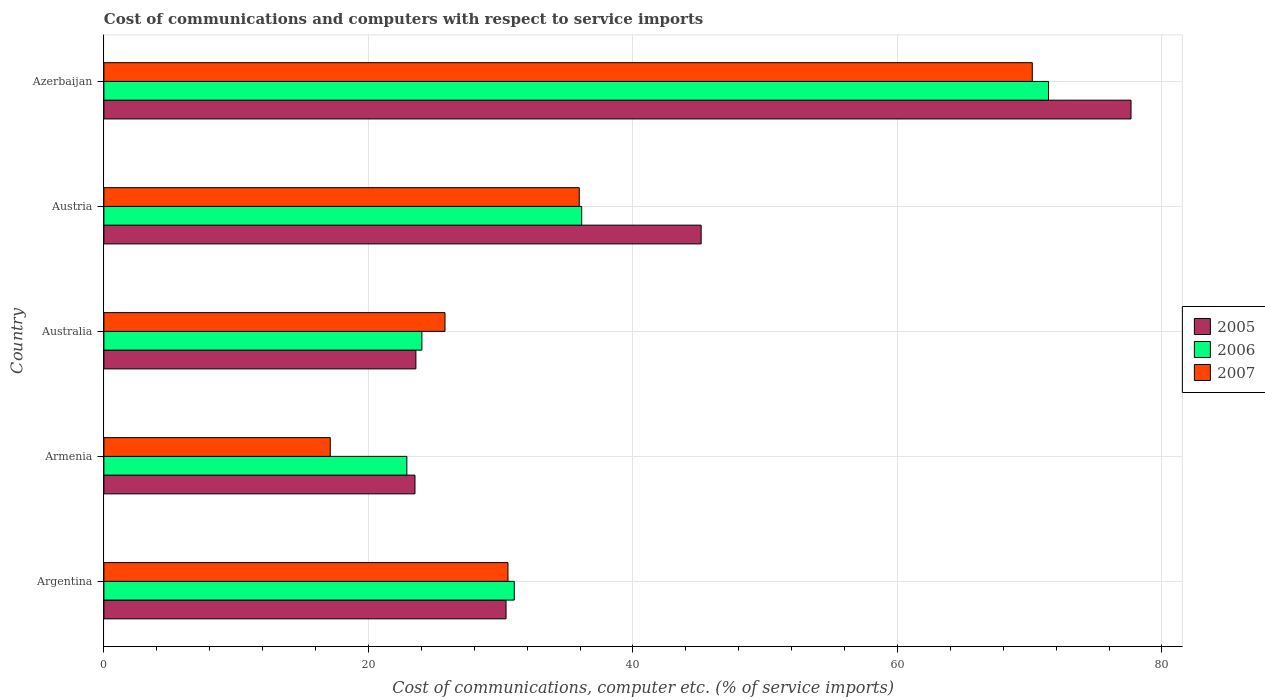Are the number of bars per tick equal to the number of legend labels?
Provide a short and direct response. Yes. Are the number of bars on each tick of the Y-axis equal?
Your response must be concise. Yes. How many bars are there on the 3rd tick from the top?
Make the answer very short. 3. What is the label of the 3rd group of bars from the top?
Provide a short and direct response. Australia. What is the cost of communications and computers in 2007 in Australia?
Make the answer very short. 25.79. Across all countries, what is the maximum cost of communications and computers in 2006?
Provide a succinct answer. 71.43. Across all countries, what is the minimum cost of communications and computers in 2006?
Your response must be concise. 22.91. In which country was the cost of communications and computers in 2005 maximum?
Make the answer very short. Azerbaijan. In which country was the cost of communications and computers in 2005 minimum?
Provide a succinct answer. Armenia. What is the total cost of communications and computers in 2005 in the graph?
Offer a terse response. 200.35. What is the difference between the cost of communications and computers in 2005 in Argentina and that in Azerbaijan?
Keep it short and to the point. -47.26. What is the difference between the cost of communications and computers in 2005 in Argentina and the cost of communications and computers in 2007 in Australia?
Your answer should be compact. 4.62. What is the average cost of communications and computers in 2005 per country?
Provide a short and direct response. 40.07. What is the difference between the cost of communications and computers in 2006 and cost of communications and computers in 2005 in Argentina?
Your response must be concise. 0.62. In how many countries, is the cost of communications and computers in 2007 greater than 40 %?
Offer a terse response. 1. What is the ratio of the cost of communications and computers in 2006 in Argentina to that in Austria?
Provide a short and direct response. 0.86. What is the difference between the highest and the second highest cost of communications and computers in 2005?
Ensure brevity in your answer.  32.5. What is the difference between the highest and the lowest cost of communications and computers in 2007?
Your response must be concise. 53.08. In how many countries, is the cost of communications and computers in 2005 greater than the average cost of communications and computers in 2005 taken over all countries?
Offer a terse response. 2. What does the 2nd bar from the top in Austria represents?
Offer a very short reply. 2006. Is it the case that in every country, the sum of the cost of communications and computers in 2005 and cost of communications and computers in 2007 is greater than the cost of communications and computers in 2006?
Ensure brevity in your answer.  Yes. How many bars are there?
Provide a succinct answer. 15. Are all the bars in the graph horizontal?
Your response must be concise. Yes. How many countries are there in the graph?
Offer a very short reply. 5. Are the values on the major ticks of X-axis written in scientific E-notation?
Offer a terse response. No. Does the graph contain any zero values?
Give a very brief answer. No. Does the graph contain grids?
Provide a succinct answer. Yes. Where does the legend appear in the graph?
Give a very brief answer. Center right. How many legend labels are there?
Provide a succinct answer. 3. What is the title of the graph?
Offer a terse response. Cost of communications and computers with respect to service imports. What is the label or title of the X-axis?
Offer a very short reply. Cost of communications, computer etc. (% of service imports). What is the Cost of communications, computer etc. (% of service imports) of 2005 in Argentina?
Offer a terse response. 30.41. What is the Cost of communications, computer etc. (% of service imports) of 2006 in Argentina?
Keep it short and to the point. 31.03. What is the Cost of communications, computer etc. (% of service imports) of 2007 in Argentina?
Make the answer very short. 30.55. What is the Cost of communications, computer etc. (% of service imports) in 2005 in Armenia?
Offer a very short reply. 23.52. What is the Cost of communications, computer etc. (% of service imports) in 2006 in Armenia?
Offer a very short reply. 22.91. What is the Cost of communications, computer etc. (% of service imports) in 2007 in Armenia?
Ensure brevity in your answer.  17.12. What is the Cost of communications, computer etc. (% of service imports) in 2005 in Australia?
Offer a very short reply. 23.59. What is the Cost of communications, computer etc. (% of service imports) in 2006 in Australia?
Provide a succinct answer. 24.05. What is the Cost of communications, computer etc. (% of service imports) in 2007 in Australia?
Your answer should be very brief. 25.79. What is the Cost of communications, computer etc. (% of service imports) of 2005 in Austria?
Offer a very short reply. 45.16. What is the Cost of communications, computer etc. (% of service imports) of 2006 in Austria?
Provide a short and direct response. 36.13. What is the Cost of communications, computer etc. (% of service imports) in 2007 in Austria?
Give a very brief answer. 35.94. What is the Cost of communications, computer etc. (% of service imports) in 2005 in Azerbaijan?
Offer a terse response. 77.66. What is the Cost of communications, computer etc. (% of service imports) of 2006 in Azerbaijan?
Make the answer very short. 71.43. What is the Cost of communications, computer etc. (% of service imports) in 2007 in Azerbaijan?
Your response must be concise. 70.2. Across all countries, what is the maximum Cost of communications, computer etc. (% of service imports) of 2005?
Provide a short and direct response. 77.66. Across all countries, what is the maximum Cost of communications, computer etc. (% of service imports) in 2006?
Ensure brevity in your answer.  71.43. Across all countries, what is the maximum Cost of communications, computer etc. (% of service imports) of 2007?
Offer a terse response. 70.2. Across all countries, what is the minimum Cost of communications, computer etc. (% of service imports) of 2005?
Your response must be concise. 23.52. Across all countries, what is the minimum Cost of communications, computer etc. (% of service imports) in 2006?
Give a very brief answer. 22.91. Across all countries, what is the minimum Cost of communications, computer etc. (% of service imports) of 2007?
Ensure brevity in your answer.  17.12. What is the total Cost of communications, computer etc. (% of service imports) in 2005 in the graph?
Your answer should be compact. 200.35. What is the total Cost of communications, computer etc. (% of service imports) of 2006 in the graph?
Provide a short and direct response. 185.54. What is the total Cost of communications, computer etc. (% of service imports) in 2007 in the graph?
Make the answer very short. 179.6. What is the difference between the Cost of communications, computer etc. (% of service imports) of 2005 in Argentina and that in Armenia?
Your answer should be compact. 6.88. What is the difference between the Cost of communications, computer etc. (% of service imports) in 2006 in Argentina and that in Armenia?
Make the answer very short. 8.12. What is the difference between the Cost of communications, computer etc. (% of service imports) of 2007 in Argentina and that in Armenia?
Your answer should be compact. 13.44. What is the difference between the Cost of communications, computer etc. (% of service imports) in 2005 in Argentina and that in Australia?
Your response must be concise. 6.82. What is the difference between the Cost of communications, computer etc. (% of service imports) of 2006 in Argentina and that in Australia?
Offer a very short reply. 6.98. What is the difference between the Cost of communications, computer etc. (% of service imports) of 2007 in Argentina and that in Australia?
Your answer should be very brief. 4.76. What is the difference between the Cost of communications, computer etc. (% of service imports) in 2005 in Argentina and that in Austria?
Provide a succinct answer. -14.75. What is the difference between the Cost of communications, computer etc. (% of service imports) in 2006 in Argentina and that in Austria?
Offer a very short reply. -5.1. What is the difference between the Cost of communications, computer etc. (% of service imports) of 2007 in Argentina and that in Austria?
Make the answer very short. -5.39. What is the difference between the Cost of communications, computer etc. (% of service imports) in 2005 in Argentina and that in Azerbaijan?
Provide a succinct answer. -47.26. What is the difference between the Cost of communications, computer etc. (% of service imports) in 2006 in Argentina and that in Azerbaijan?
Keep it short and to the point. -40.4. What is the difference between the Cost of communications, computer etc. (% of service imports) of 2007 in Argentina and that in Azerbaijan?
Offer a very short reply. -39.65. What is the difference between the Cost of communications, computer etc. (% of service imports) of 2005 in Armenia and that in Australia?
Give a very brief answer. -0.07. What is the difference between the Cost of communications, computer etc. (% of service imports) in 2006 in Armenia and that in Australia?
Give a very brief answer. -1.14. What is the difference between the Cost of communications, computer etc. (% of service imports) in 2007 in Armenia and that in Australia?
Make the answer very short. -8.68. What is the difference between the Cost of communications, computer etc. (% of service imports) of 2005 in Armenia and that in Austria?
Your answer should be very brief. -21.64. What is the difference between the Cost of communications, computer etc. (% of service imports) of 2006 in Armenia and that in Austria?
Offer a terse response. -13.22. What is the difference between the Cost of communications, computer etc. (% of service imports) in 2007 in Armenia and that in Austria?
Give a very brief answer. -18.83. What is the difference between the Cost of communications, computer etc. (% of service imports) in 2005 in Armenia and that in Azerbaijan?
Ensure brevity in your answer.  -54.14. What is the difference between the Cost of communications, computer etc. (% of service imports) in 2006 in Armenia and that in Azerbaijan?
Ensure brevity in your answer.  -48.52. What is the difference between the Cost of communications, computer etc. (% of service imports) of 2007 in Armenia and that in Azerbaijan?
Give a very brief answer. -53.08. What is the difference between the Cost of communications, computer etc. (% of service imports) in 2005 in Australia and that in Austria?
Keep it short and to the point. -21.57. What is the difference between the Cost of communications, computer etc. (% of service imports) in 2006 in Australia and that in Austria?
Keep it short and to the point. -12.08. What is the difference between the Cost of communications, computer etc. (% of service imports) in 2007 in Australia and that in Austria?
Provide a succinct answer. -10.15. What is the difference between the Cost of communications, computer etc. (% of service imports) of 2005 in Australia and that in Azerbaijan?
Your answer should be very brief. -54.07. What is the difference between the Cost of communications, computer etc. (% of service imports) in 2006 in Australia and that in Azerbaijan?
Provide a succinct answer. -47.38. What is the difference between the Cost of communications, computer etc. (% of service imports) in 2007 in Australia and that in Azerbaijan?
Keep it short and to the point. -44.41. What is the difference between the Cost of communications, computer etc. (% of service imports) in 2005 in Austria and that in Azerbaijan?
Ensure brevity in your answer.  -32.5. What is the difference between the Cost of communications, computer etc. (% of service imports) in 2006 in Austria and that in Azerbaijan?
Your answer should be compact. -35.3. What is the difference between the Cost of communications, computer etc. (% of service imports) of 2007 in Austria and that in Azerbaijan?
Your answer should be very brief. -34.26. What is the difference between the Cost of communications, computer etc. (% of service imports) of 2005 in Argentina and the Cost of communications, computer etc. (% of service imports) of 2007 in Armenia?
Your answer should be compact. 13.29. What is the difference between the Cost of communications, computer etc. (% of service imports) of 2006 in Argentina and the Cost of communications, computer etc. (% of service imports) of 2007 in Armenia?
Ensure brevity in your answer.  13.91. What is the difference between the Cost of communications, computer etc. (% of service imports) in 2005 in Argentina and the Cost of communications, computer etc. (% of service imports) in 2006 in Australia?
Offer a very short reply. 6.36. What is the difference between the Cost of communications, computer etc. (% of service imports) in 2005 in Argentina and the Cost of communications, computer etc. (% of service imports) in 2007 in Australia?
Ensure brevity in your answer.  4.62. What is the difference between the Cost of communications, computer etc. (% of service imports) of 2006 in Argentina and the Cost of communications, computer etc. (% of service imports) of 2007 in Australia?
Your answer should be very brief. 5.24. What is the difference between the Cost of communications, computer etc. (% of service imports) in 2005 in Argentina and the Cost of communications, computer etc. (% of service imports) in 2006 in Austria?
Offer a very short reply. -5.72. What is the difference between the Cost of communications, computer etc. (% of service imports) of 2005 in Argentina and the Cost of communications, computer etc. (% of service imports) of 2007 in Austria?
Offer a very short reply. -5.54. What is the difference between the Cost of communications, computer etc. (% of service imports) of 2006 in Argentina and the Cost of communications, computer etc. (% of service imports) of 2007 in Austria?
Your response must be concise. -4.91. What is the difference between the Cost of communications, computer etc. (% of service imports) in 2005 in Argentina and the Cost of communications, computer etc. (% of service imports) in 2006 in Azerbaijan?
Provide a short and direct response. -41.02. What is the difference between the Cost of communications, computer etc. (% of service imports) in 2005 in Argentina and the Cost of communications, computer etc. (% of service imports) in 2007 in Azerbaijan?
Give a very brief answer. -39.79. What is the difference between the Cost of communications, computer etc. (% of service imports) in 2006 in Argentina and the Cost of communications, computer etc. (% of service imports) in 2007 in Azerbaijan?
Provide a succinct answer. -39.17. What is the difference between the Cost of communications, computer etc. (% of service imports) of 2005 in Armenia and the Cost of communications, computer etc. (% of service imports) of 2006 in Australia?
Keep it short and to the point. -0.52. What is the difference between the Cost of communications, computer etc. (% of service imports) in 2005 in Armenia and the Cost of communications, computer etc. (% of service imports) in 2007 in Australia?
Provide a succinct answer. -2.27. What is the difference between the Cost of communications, computer etc. (% of service imports) of 2006 in Armenia and the Cost of communications, computer etc. (% of service imports) of 2007 in Australia?
Offer a terse response. -2.88. What is the difference between the Cost of communications, computer etc. (% of service imports) of 2005 in Armenia and the Cost of communications, computer etc. (% of service imports) of 2006 in Austria?
Keep it short and to the point. -12.6. What is the difference between the Cost of communications, computer etc. (% of service imports) of 2005 in Armenia and the Cost of communications, computer etc. (% of service imports) of 2007 in Austria?
Offer a terse response. -12.42. What is the difference between the Cost of communications, computer etc. (% of service imports) of 2006 in Armenia and the Cost of communications, computer etc. (% of service imports) of 2007 in Austria?
Your answer should be compact. -13.04. What is the difference between the Cost of communications, computer etc. (% of service imports) in 2005 in Armenia and the Cost of communications, computer etc. (% of service imports) in 2006 in Azerbaijan?
Provide a short and direct response. -47.91. What is the difference between the Cost of communications, computer etc. (% of service imports) in 2005 in Armenia and the Cost of communications, computer etc. (% of service imports) in 2007 in Azerbaijan?
Your answer should be very brief. -46.68. What is the difference between the Cost of communications, computer etc. (% of service imports) of 2006 in Armenia and the Cost of communications, computer etc. (% of service imports) of 2007 in Azerbaijan?
Your response must be concise. -47.29. What is the difference between the Cost of communications, computer etc. (% of service imports) in 2005 in Australia and the Cost of communications, computer etc. (% of service imports) in 2006 in Austria?
Ensure brevity in your answer.  -12.54. What is the difference between the Cost of communications, computer etc. (% of service imports) of 2005 in Australia and the Cost of communications, computer etc. (% of service imports) of 2007 in Austria?
Provide a short and direct response. -12.35. What is the difference between the Cost of communications, computer etc. (% of service imports) in 2006 in Australia and the Cost of communications, computer etc. (% of service imports) in 2007 in Austria?
Ensure brevity in your answer.  -11.9. What is the difference between the Cost of communications, computer etc. (% of service imports) in 2005 in Australia and the Cost of communications, computer etc. (% of service imports) in 2006 in Azerbaijan?
Offer a very short reply. -47.84. What is the difference between the Cost of communications, computer etc. (% of service imports) in 2005 in Australia and the Cost of communications, computer etc. (% of service imports) in 2007 in Azerbaijan?
Make the answer very short. -46.61. What is the difference between the Cost of communications, computer etc. (% of service imports) of 2006 in Australia and the Cost of communications, computer etc. (% of service imports) of 2007 in Azerbaijan?
Provide a succinct answer. -46.15. What is the difference between the Cost of communications, computer etc. (% of service imports) of 2005 in Austria and the Cost of communications, computer etc. (% of service imports) of 2006 in Azerbaijan?
Keep it short and to the point. -26.27. What is the difference between the Cost of communications, computer etc. (% of service imports) of 2005 in Austria and the Cost of communications, computer etc. (% of service imports) of 2007 in Azerbaijan?
Your response must be concise. -25.04. What is the difference between the Cost of communications, computer etc. (% of service imports) of 2006 in Austria and the Cost of communications, computer etc. (% of service imports) of 2007 in Azerbaijan?
Make the answer very short. -34.07. What is the average Cost of communications, computer etc. (% of service imports) in 2005 per country?
Your answer should be very brief. 40.07. What is the average Cost of communications, computer etc. (% of service imports) in 2006 per country?
Your answer should be very brief. 37.11. What is the average Cost of communications, computer etc. (% of service imports) of 2007 per country?
Your answer should be compact. 35.92. What is the difference between the Cost of communications, computer etc. (% of service imports) of 2005 and Cost of communications, computer etc. (% of service imports) of 2006 in Argentina?
Keep it short and to the point. -0.62. What is the difference between the Cost of communications, computer etc. (% of service imports) in 2005 and Cost of communications, computer etc. (% of service imports) in 2007 in Argentina?
Keep it short and to the point. -0.15. What is the difference between the Cost of communications, computer etc. (% of service imports) in 2006 and Cost of communications, computer etc. (% of service imports) in 2007 in Argentina?
Your response must be concise. 0.48. What is the difference between the Cost of communications, computer etc. (% of service imports) in 2005 and Cost of communications, computer etc. (% of service imports) in 2006 in Armenia?
Give a very brief answer. 0.61. What is the difference between the Cost of communications, computer etc. (% of service imports) in 2005 and Cost of communications, computer etc. (% of service imports) in 2007 in Armenia?
Your answer should be very brief. 6.41. What is the difference between the Cost of communications, computer etc. (% of service imports) of 2006 and Cost of communications, computer etc. (% of service imports) of 2007 in Armenia?
Your response must be concise. 5.79. What is the difference between the Cost of communications, computer etc. (% of service imports) of 2005 and Cost of communications, computer etc. (% of service imports) of 2006 in Australia?
Give a very brief answer. -0.45. What is the difference between the Cost of communications, computer etc. (% of service imports) of 2005 and Cost of communications, computer etc. (% of service imports) of 2007 in Australia?
Offer a very short reply. -2.2. What is the difference between the Cost of communications, computer etc. (% of service imports) of 2006 and Cost of communications, computer etc. (% of service imports) of 2007 in Australia?
Make the answer very short. -1.75. What is the difference between the Cost of communications, computer etc. (% of service imports) in 2005 and Cost of communications, computer etc. (% of service imports) in 2006 in Austria?
Keep it short and to the point. 9.03. What is the difference between the Cost of communications, computer etc. (% of service imports) of 2005 and Cost of communications, computer etc. (% of service imports) of 2007 in Austria?
Make the answer very short. 9.22. What is the difference between the Cost of communications, computer etc. (% of service imports) of 2006 and Cost of communications, computer etc. (% of service imports) of 2007 in Austria?
Offer a terse response. 0.18. What is the difference between the Cost of communications, computer etc. (% of service imports) in 2005 and Cost of communications, computer etc. (% of service imports) in 2006 in Azerbaijan?
Give a very brief answer. 6.24. What is the difference between the Cost of communications, computer etc. (% of service imports) of 2005 and Cost of communications, computer etc. (% of service imports) of 2007 in Azerbaijan?
Offer a terse response. 7.46. What is the difference between the Cost of communications, computer etc. (% of service imports) of 2006 and Cost of communications, computer etc. (% of service imports) of 2007 in Azerbaijan?
Your answer should be compact. 1.23. What is the ratio of the Cost of communications, computer etc. (% of service imports) in 2005 in Argentina to that in Armenia?
Make the answer very short. 1.29. What is the ratio of the Cost of communications, computer etc. (% of service imports) of 2006 in Argentina to that in Armenia?
Give a very brief answer. 1.35. What is the ratio of the Cost of communications, computer etc. (% of service imports) in 2007 in Argentina to that in Armenia?
Ensure brevity in your answer.  1.78. What is the ratio of the Cost of communications, computer etc. (% of service imports) of 2005 in Argentina to that in Australia?
Provide a succinct answer. 1.29. What is the ratio of the Cost of communications, computer etc. (% of service imports) of 2006 in Argentina to that in Australia?
Give a very brief answer. 1.29. What is the ratio of the Cost of communications, computer etc. (% of service imports) in 2007 in Argentina to that in Australia?
Your response must be concise. 1.18. What is the ratio of the Cost of communications, computer etc. (% of service imports) in 2005 in Argentina to that in Austria?
Your answer should be compact. 0.67. What is the ratio of the Cost of communications, computer etc. (% of service imports) of 2006 in Argentina to that in Austria?
Your answer should be compact. 0.86. What is the ratio of the Cost of communications, computer etc. (% of service imports) of 2007 in Argentina to that in Austria?
Your answer should be very brief. 0.85. What is the ratio of the Cost of communications, computer etc. (% of service imports) of 2005 in Argentina to that in Azerbaijan?
Give a very brief answer. 0.39. What is the ratio of the Cost of communications, computer etc. (% of service imports) of 2006 in Argentina to that in Azerbaijan?
Make the answer very short. 0.43. What is the ratio of the Cost of communications, computer etc. (% of service imports) in 2007 in Argentina to that in Azerbaijan?
Make the answer very short. 0.44. What is the ratio of the Cost of communications, computer etc. (% of service imports) in 2006 in Armenia to that in Australia?
Your response must be concise. 0.95. What is the ratio of the Cost of communications, computer etc. (% of service imports) in 2007 in Armenia to that in Australia?
Your answer should be very brief. 0.66. What is the ratio of the Cost of communications, computer etc. (% of service imports) of 2005 in Armenia to that in Austria?
Provide a succinct answer. 0.52. What is the ratio of the Cost of communications, computer etc. (% of service imports) of 2006 in Armenia to that in Austria?
Make the answer very short. 0.63. What is the ratio of the Cost of communications, computer etc. (% of service imports) in 2007 in Armenia to that in Austria?
Provide a succinct answer. 0.48. What is the ratio of the Cost of communications, computer etc. (% of service imports) in 2005 in Armenia to that in Azerbaijan?
Ensure brevity in your answer.  0.3. What is the ratio of the Cost of communications, computer etc. (% of service imports) of 2006 in Armenia to that in Azerbaijan?
Give a very brief answer. 0.32. What is the ratio of the Cost of communications, computer etc. (% of service imports) in 2007 in Armenia to that in Azerbaijan?
Offer a terse response. 0.24. What is the ratio of the Cost of communications, computer etc. (% of service imports) in 2005 in Australia to that in Austria?
Offer a terse response. 0.52. What is the ratio of the Cost of communications, computer etc. (% of service imports) of 2006 in Australia to that in Austria?
Keep it short and to the point. 0.67. What is the ratio of the Cost of communications, computer etc. (% of service imports) of 2007 in Australia to that in Austria?
Your answer should be very brief. 0.72. What is the ratio of the Cost of communications, computer etc. (% of service imports) in 2005 in Australia to that in Azerbaijan?
Give a very brief answer. 0.3. What is the ratio of the Cost of communications, computer etc. (% of service imports) in 2006 in Australia to that in Azerbaijan?
Your response must be concise. 0.34. What is the ratio of the Cost of communications, computer etc. (% of service imports) in 2007 in Australia to that in Azerbaijan?
Ensure brevity in your answer.  0.37. What is the ratio of the Cost of communications, computer etc. (% of service imports) in 2005 in Austria to that in Azerbaijan?
Your answer should be compact. 0.58. What is the ratio of the Cost of communications, computer etc. (% of service imports) of 2006 in Austria to that in Azerbaijan?
Your answer should be compact. 0.51. What is the ratio of the Cost of communications, computer etc. (% of service imports) in 2007 in Austria to that in Azerbaijan?
Your response must be concise. 0.51. What is the difference between the highest and the second highest Cost of communications, computer etc. (% of service imports) in 2005?
Your response must be concise. 32.5. What is the difference between the highest and the second highest Cost of communications, computer etc. (% of service imports) of 2006?
Give a very brief answer. 35.3. What is the difference between the highest and the second highest Cost of communications, computer etc. (% of service imports) in 2007?
Your answer should be compact. 34.26. What is the difference between the highest and the lowest Cost of communications, computer etc. (% of service imports) of 2005?
Give a very brief answer. 54.14. What is the difference between the highest and the lowest Cost of communications, computer etc. (% of service imports) of 2006?
Your answer should be compact. 48.52. What is the difference between the highest and the lowest Cost of communications, computer etc. (% of service imports) in 2007?
Your answer should be compact. 53.08. 